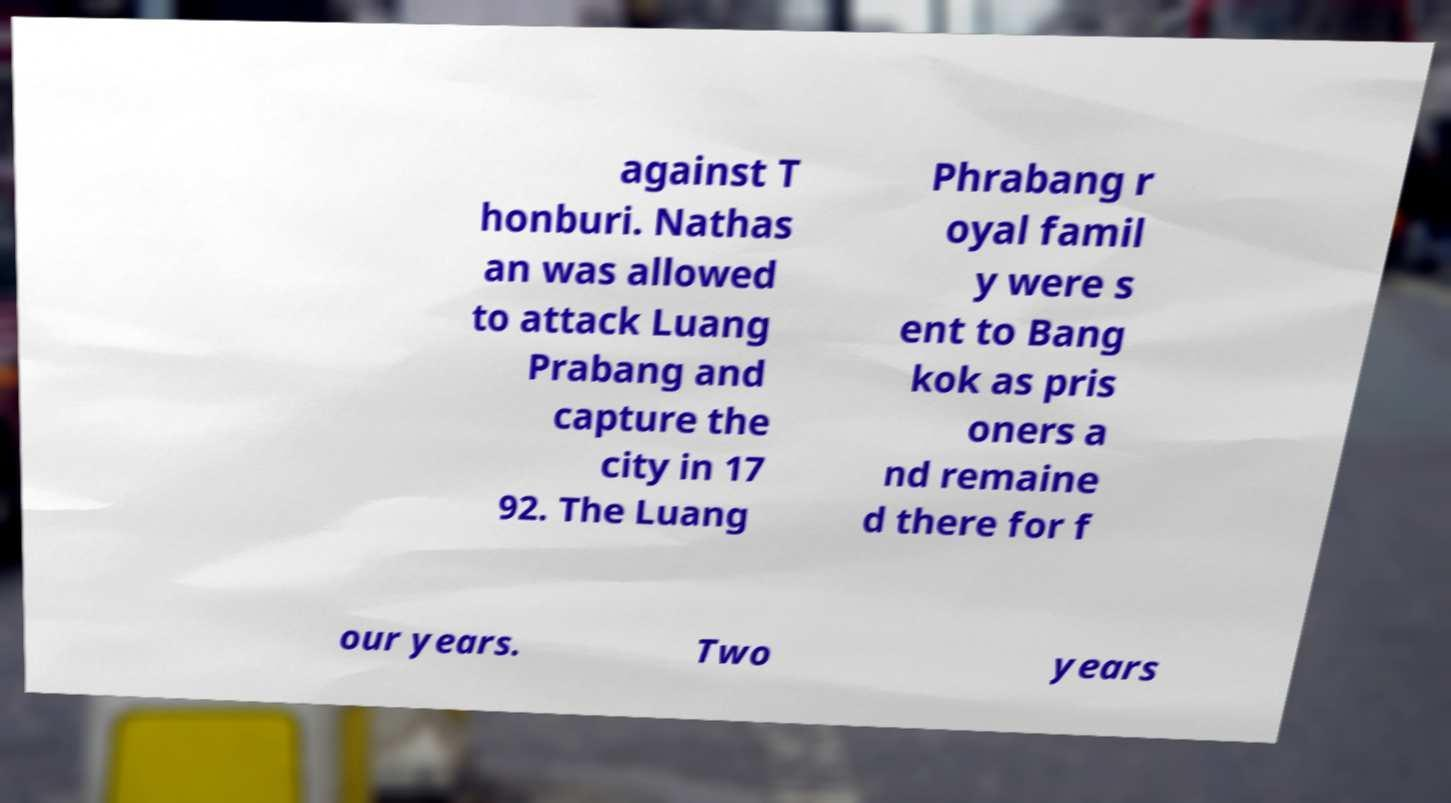For documentation purposes, I need the text within this image transcribed. Could you provide that? against T honburi. Nathas an was allowed to attack Luang Prabang and capture the city in 17 92. The Luang Phrabang r oyal famil y were s ent to Bang kok as pris oners a nd remaine d there for f our years. Two years 